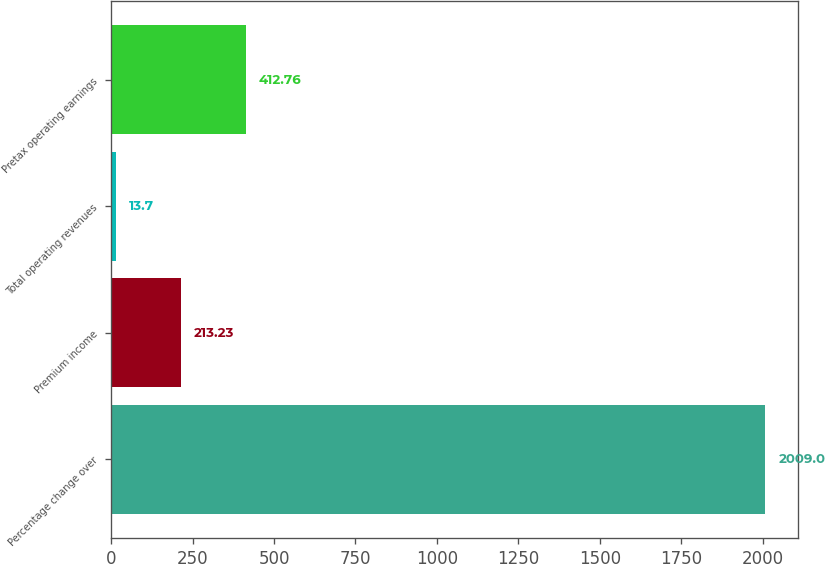<chart> <loc_0><loc_0><loc_500><loc_500><bar_chart><fcel>Percentage change over<fcel>Premium income<fcel>Total operating revenues<fcel>Pretax operating earnings<nl><fcel>2009<fcel>213.23<fcel>13.7<fcel>412.76<nl></chart> 